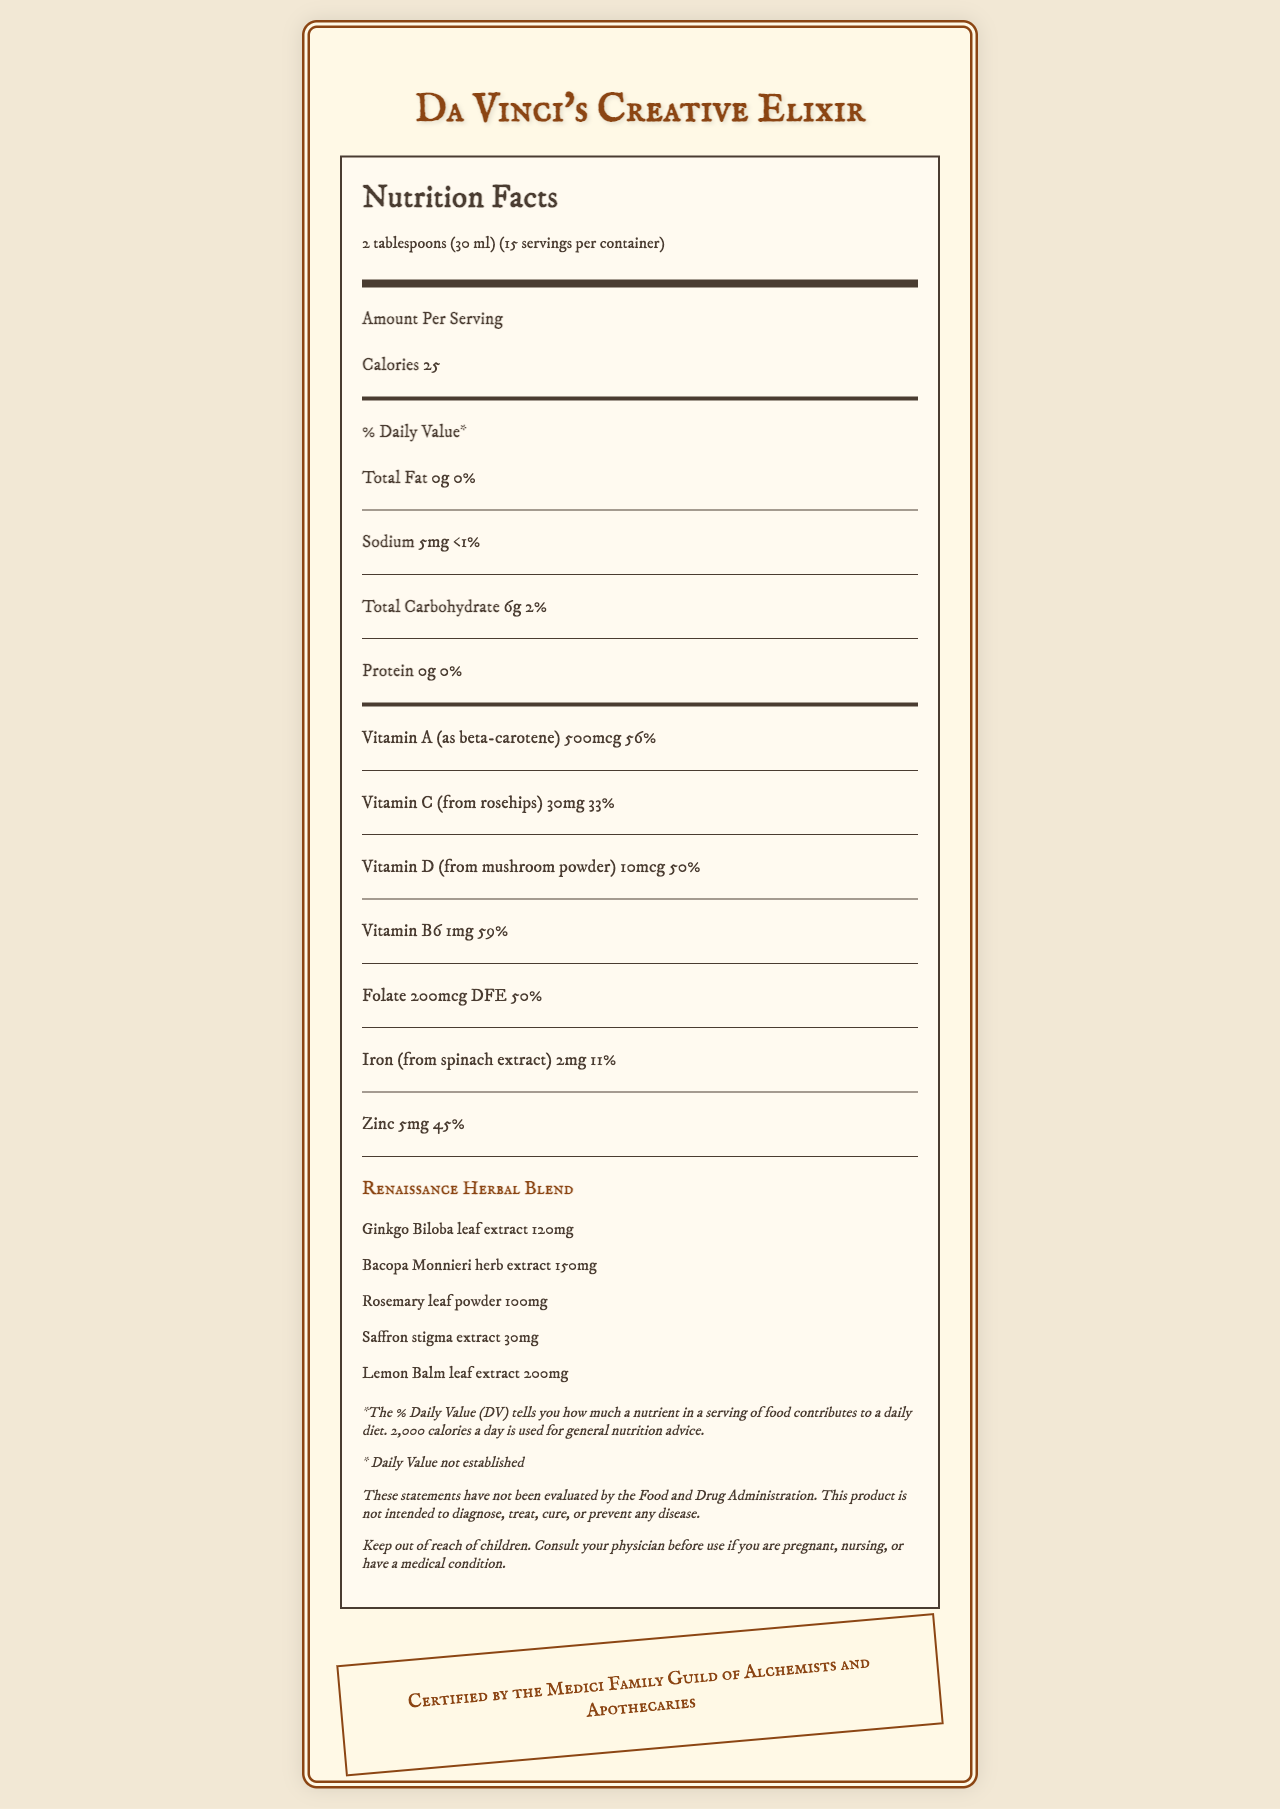what is the serving size of Da Vinci's Creative Elixir? The serving size is mentioned at the top of the Nutrition Facts as "2 tablespoons (30 ml)."
Answer: 2 tablespoons (30 ml) how many servings are there per container? The container has 15 servings as stated near the top under the serving size information.
Answer: 15 how many calories are in each serving? Each serving of the elixir contains 25 calories, as written under the "Amount Per Serving" section.
Answer: 25 what percentage of the daily value of Vitamin C does one serving provide? The Vitamin C daily value is listed as 33%, which is part of the detailed vitamin and mineral information.
Answer: 33% which ingredient contributes the highest amount to the Renaissance Herbal Blend by weight? The Lemon Balm leaf extract contributes the highest amount with 200mg according to the "Renaissance Herbal Blend" section.
Answer: Lemon Balm leaf extract what is the amount of protein in each serving? A. 0g B. 1g C. 5g D. 10g The amount of protein in each serving is 0g, as specified under the protein section.
Answer: A what is the primary source of Vitamin D in the elixir? A. Rosehips B. Mushroom powder C. Spinach extract D. Ginkgo Biloba leaf extract The primary source of Vitamin D, as stated, is mushroom powder.
Answer: B how many mg of sodium are there in one serving? A. 0mg B. 5mg C. 10mg D. 15mg Each serving contains 5mg of sodium.
Answer: B is the elixir certified by any organization? The elixir is certified by the Medici Family Guild of Alchemists and Apothecaries, as indicated by the Renaissance Authenticity Seal.
Answer: Yes should the elixir be kept out of reach of children? The disclaimer section advises to keep the elixir out of reach of children.
Answer: Yes summarize the main idea of the document. This summary encapsulates the main elements found within the Nutrition Facts label, including key nutritional information, special herbal ingredients, and important disclaimers and certifications.
Answer: The document is a detailed Nutrition Facts label for "Da Vinci's Creative Elixir," an herbal supplement inspired by the Renaissance era, believed to enhance creativity. It includes detailed information on serving size, calories, vitamins, minerals, and an herbal blend with various extracts. Additionally, it contains disclaimers and certification information. how much honey is used in the ingredients? The document lists "Honey" as one of the ingredients but does not specify the amount.
Answer: Not enough information 